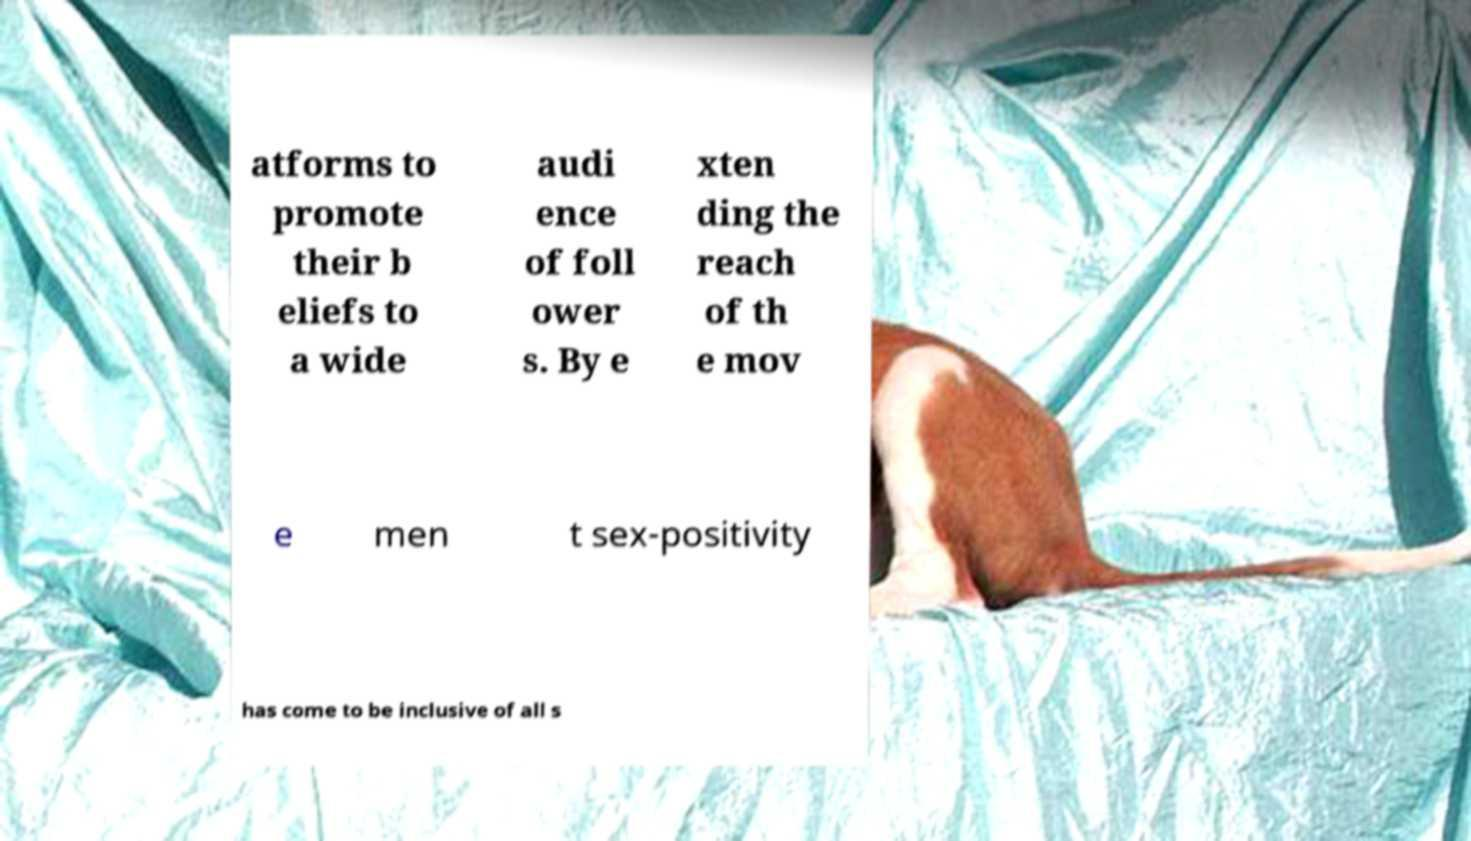There's text embedded in this image that I need extracted. Can you transcribe it verbatim? atforms to promote their b eliefs to a wide audi ence of foll ower s. By e xten ding the reach of th e mov e men t sex-positivity has come to be inclusive of all s 